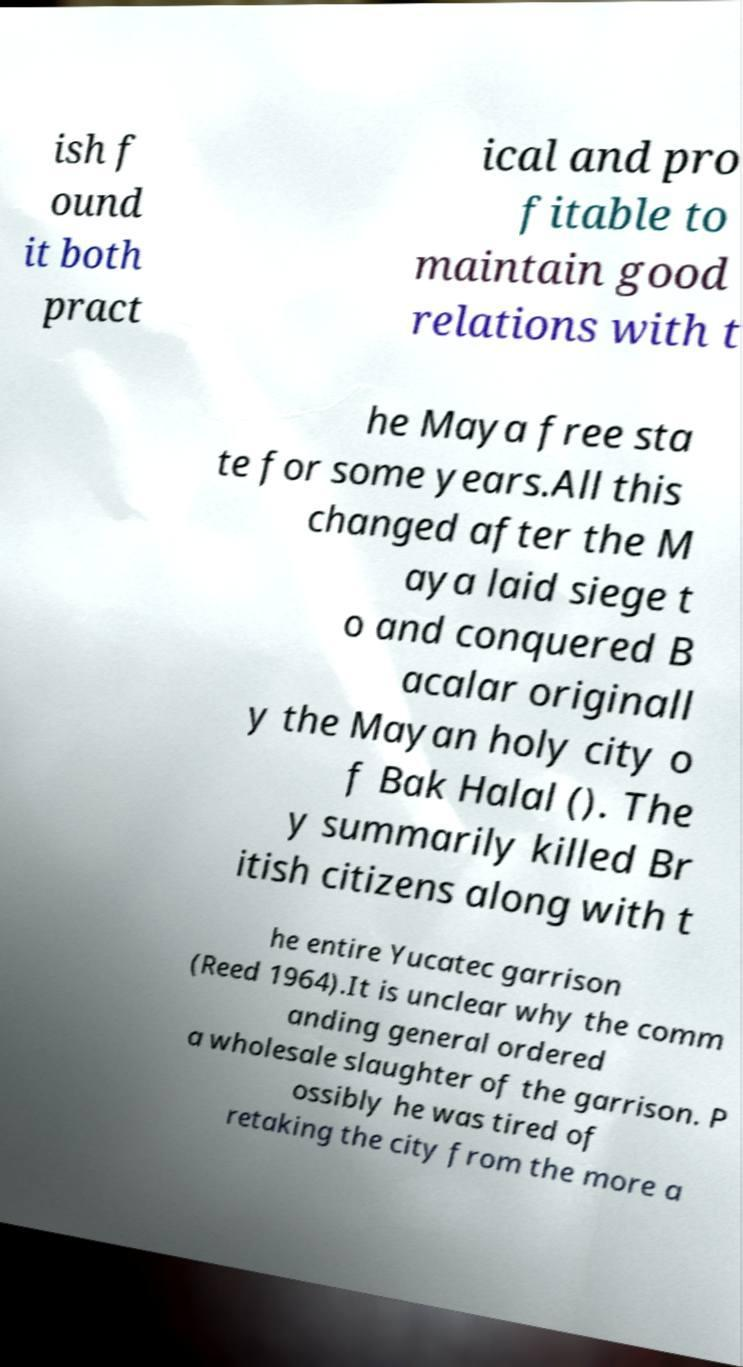Can you read and provide the text displayed in the image?This photo seems to have some interesting text. Can you extract and type it out for me? ish f ound it both pract ical and pro fitable to maintain good relations with t he Maya free sta te for some years.All this changed after the M aya laid siege t o and conquered B acalar originall y the Mayan holy city o f Bak Halal (). The y summarily killed Br itish citizens along with t he entire Yucatec garrison (Reed 1964).It is unclear why the comm anding general ordered a wholesale slaughter of the garrison. P ossibly he was tired of retaking the city from the more a 